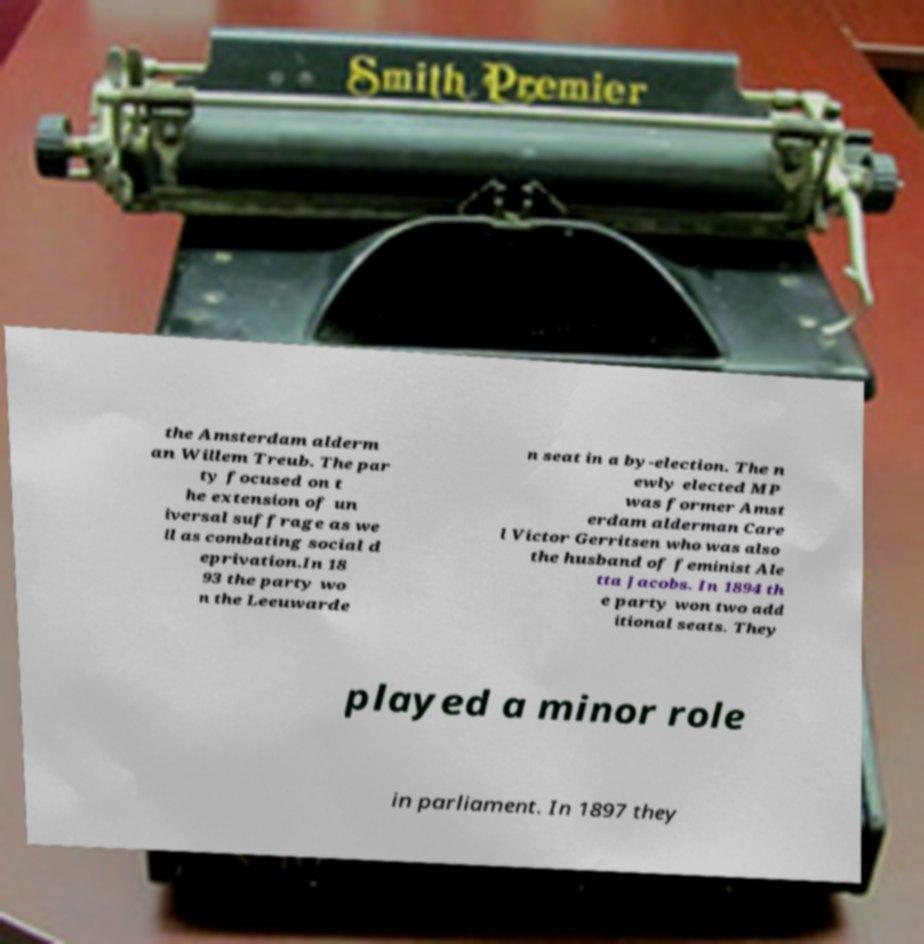Please identify and transcribe the text found in this image. the Amsterdam alderm an Willem Treub. The par ty focused on t he extension of un iversal suffrage as we ll as combating social d eprivation.In 18 93 the party wo n the Leeuwarde n seat in a by-election. The n ewly elected MP was former Amst erdam alderman Care l Victor Gerritsen who was also the husband of feminist Ale tta Jacobs. In 1894 th e party won two add itional seats. They played a minor role in parliament. In 1897 they 